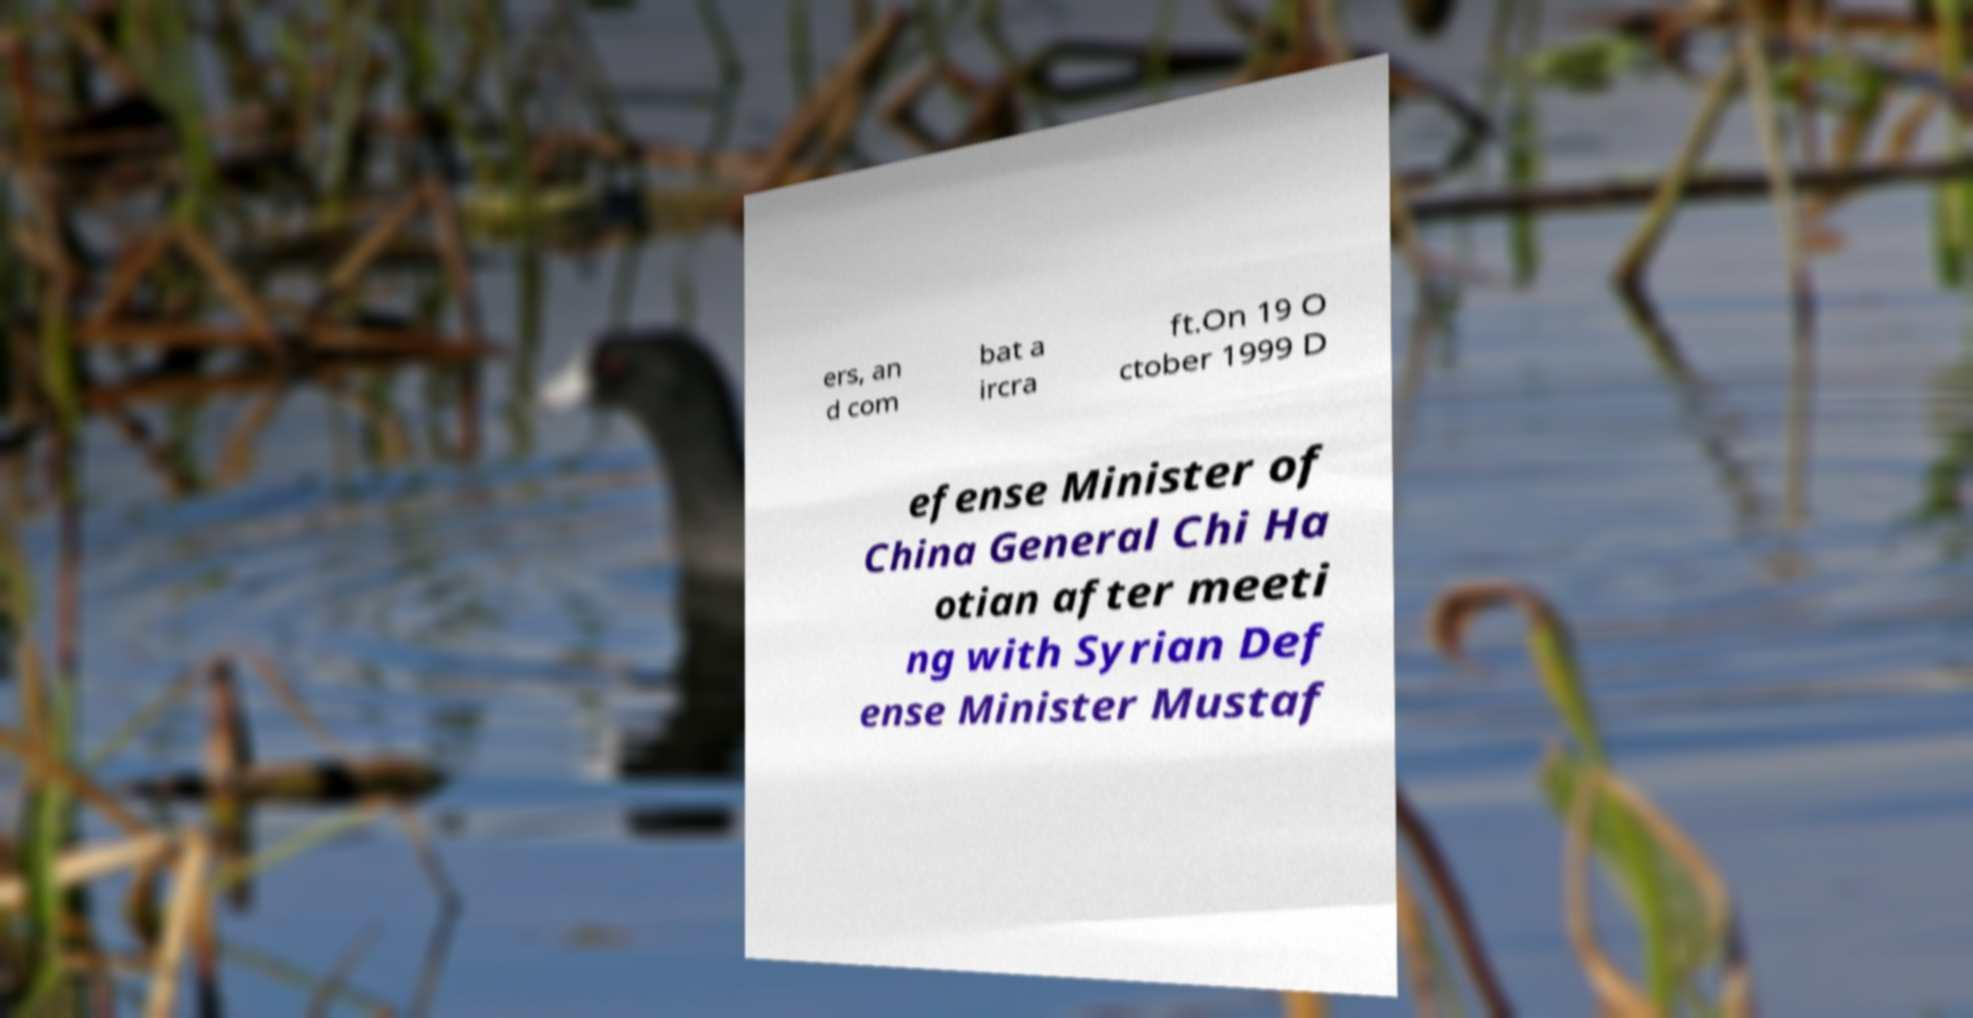Could you extract and type out the text from this image? ers, an d com bat a ircra ft.On 19 O ctober 1999 D efense Minister of China General Chi Ha otian after meeti ng with Syrian Def ense Minister Mustaf 